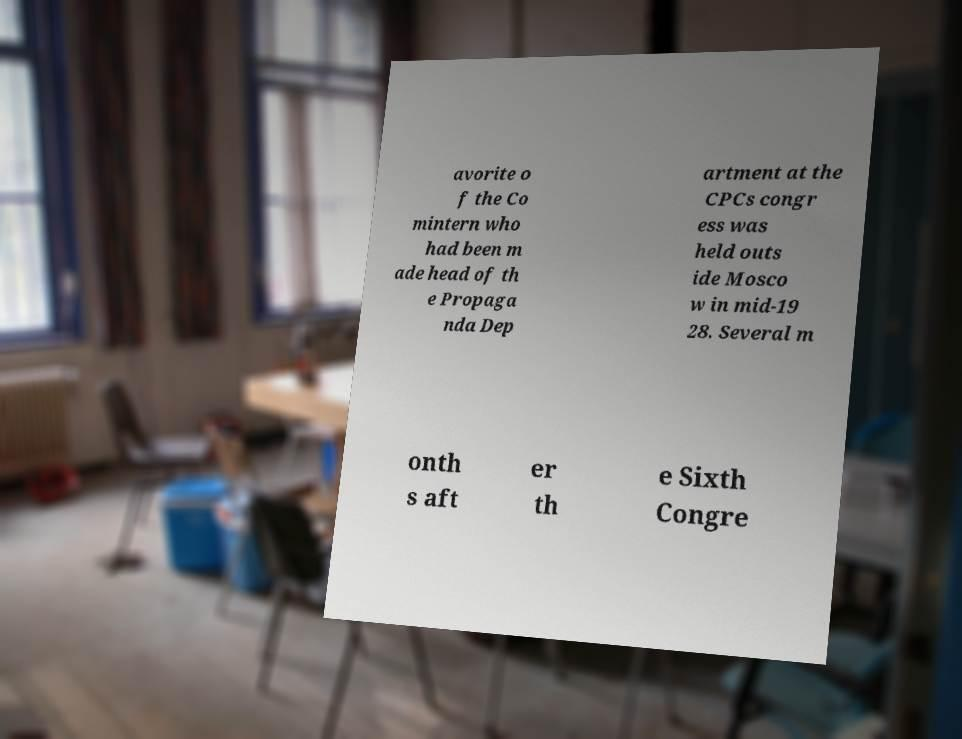Can you accurately transcribe the text from the provided image for me? avorite o f the Co mintern who had been m ade head of th e Propaga nda Dep artment at the CPCs congr ess was held outs ide Mosco w in mid-19 28. Several m onth s aft er th e Sixth Congre 